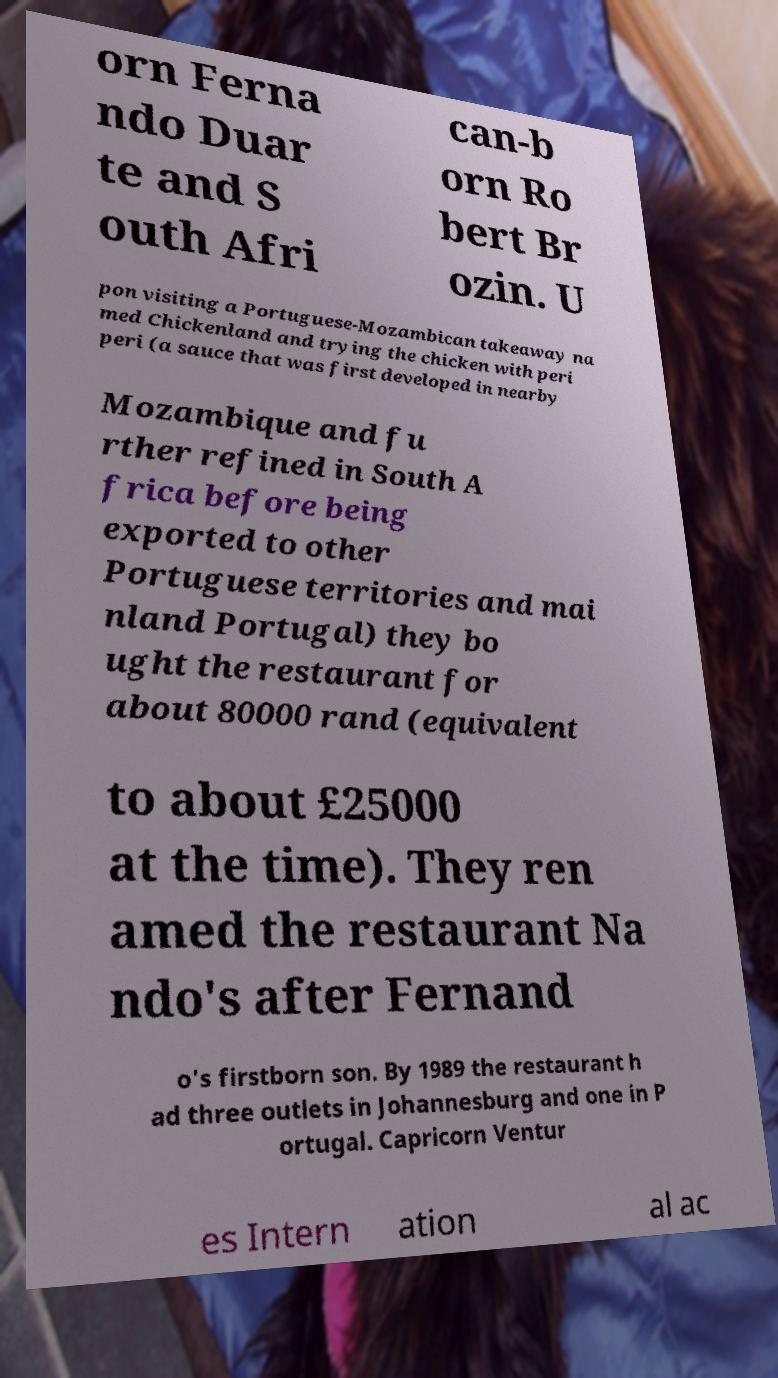What messages or text are displayed in this image? I need them in a readable, typed format. orn Ferna ndo Duar te and S outh Afri can-b orn Ro bert Br ozin. U pon visiting a Portuguese-Mozambican takeaway na med Chickenland and trying the chicken with peri peri (a sauce that was first developed in nearby Mozambique and fu rther refined in South A frica before being exported to other Portuguese territories and mai nland Portugal) they bo ught the restaurant for about 80000 rand (equivalent to about £25000 at the time). They ren amed the restaurant Na ndo's after Fernand o's firstborn son. By 1989 the restaurant h ad three outlets in Johannesburg and one in P ortugal. Capricorn Ventur es Intern ation al ac 